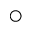Convert formula to latex. <formula><loc_0><loc_0><loc_500><loc_500>\bigcirc</formula> 